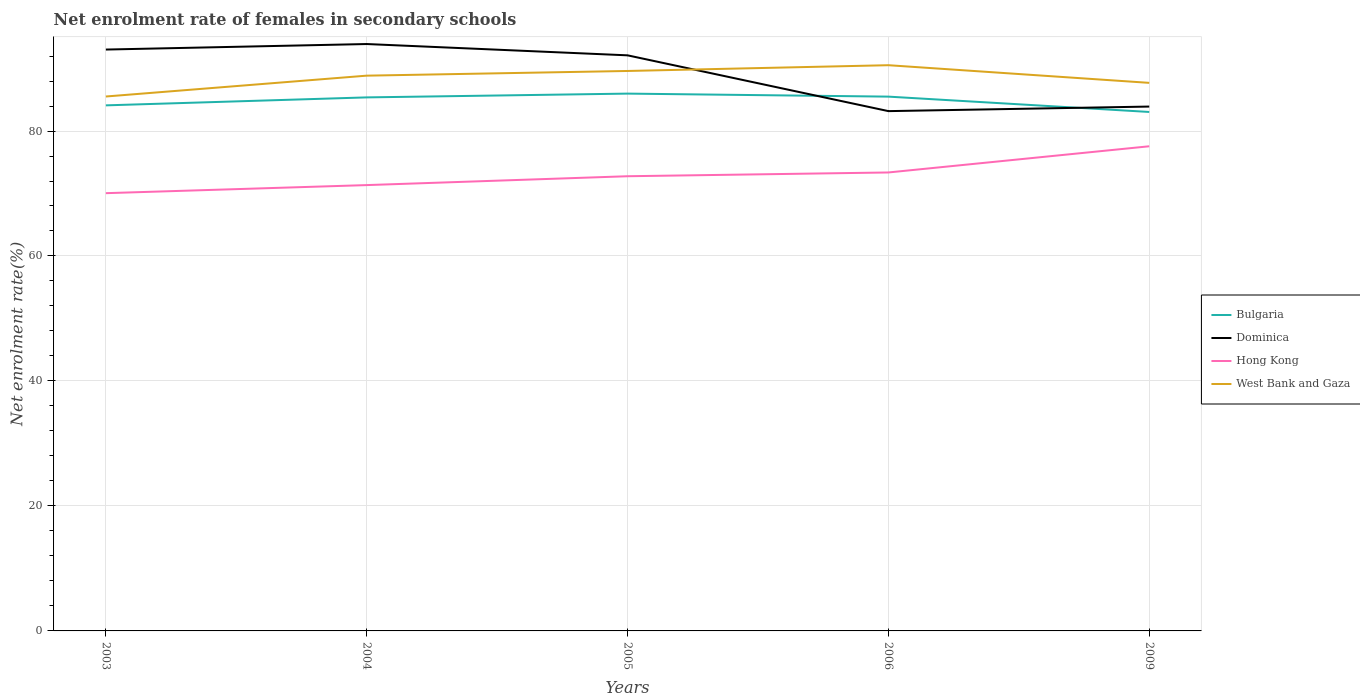Does the line corresponding to West Bank and Gaza intersect with the line corresponding to Dominica?
Provide a succinct answer. Yes. Is the number of lines equal to the number of legend labels?
Offer a terse response. Yes. Across all years, what is the maximum net enrolment rate of females in secondary schools in Hong Kong?
Provide a succinct answer. 70.05. What is the total net enrolment rate of females in secondary schools in Bulgaria in the graph?
Offer a very short reply. 0.48. What is the difference between the highest and the second highest net enrolment rate of females in secondary schools in Bulgaria?
Ensure brevity in your answer.  2.94. What is the difference between the highest and the lowest net enrolment rate of females in secondary schools in West Bank and Gaza?
Provide a short and direct response. 3. What is the difference between two consecutive major ticks on the Y-axis?
Keep it short and to the point. 20. Are the values on the major ticks of Y-axis written in scientific E-notation?
Give a very brief answer. No. Does the graph contain grids?
Your answer should be very brief. Yes. How many legend labels are there?
Make the answer very short. 4. What is the title of the graph?
Offer a terse response. Net enrolment rate of females in secondary schools. What is the label or title of the Y-axis?
Keep it short and to the point. Net enrolment rate(%). What is the Net enrolment rate(%) in Bulgaria in 2003?
Make the answer very short. 84.11. What is the Net enrolment rate(%) in Dominica in 2003?
Provide a short and direct response. 93.04. What is the Net enrolment rate(%) of Hong Kong in 2003?
Make the answer very short. 70.05. What is the Net enrolment rate(%) of West Bank and Gaza in 2003?
Provide a short and direct response. 85.52. What is the Net enrolment rate(%) in Bulgaria in 2004?
Make the answer very short. 85.38. What is the Net enrolment rate(%) of Dominica in 2004?
Give a very brief answer. 93.92. What is the Net enrolment rate(%) in Hong Kong in 2004?
Your answer should be very brief. 71.35. What is the Net enrolment rate(%) of West Bank and Gaza in 2004?
Your answer should be compact. 88.86. What is the Net enrolment rate(%) of Bulgaria in 2005?
Provide a succinct answer. 85.99. What is the Net enrolment rate(%) in Dominica in 2005?
Ensure brevity in your answer.  92.11. What is the Net enrolment rate(%) of Hong Kong in 2005?
Your response must be concise. 72.76. What is the Net enrolment rate(%) in West Bank and Gaza in 2005?
Keep it short and to the point. 89.61. What is the Net enrolment rate(%) in Bulgaria in 2006?
Offer a very short reply. 85.5. What is the Net enrolment rate(%) in Dominica in 2006?
Give a very brief answer. 83.18. What is the Net enrolment rate(%) of Hong Kong in 2006?
Your answer should be very brief. 73.37. What is the Net enrolment rate(%) of West Bank and Gaza in 2006?
Your answer should be compact. 90.53. What is the Net enrolment rate(%) in Bulgaria in 2009?
Offer a very short reply. 83.05. What is the Net enrolment rate(%) of Dominica in 2009?
Offer a very short reply. 83.91. What is the Net enrolment rate(%) of Hong Kong in 2009?
Your response must be concise. 77.56. What is the Net enrolment rate(%) of West Bank and Gaza in 2009?
Your answer should be very brief. 87.71. Across all years, what is the maximum Net enrolment rate(%) of Bulgaria?
Offer a terse response. 85.99. Across all years, what is the maximum Net enrolment rate(%) of Dominica?
Give a very brief answer. 93.92. Across all years, what is the maximum Net enrolment rate(%) in Hong Kong?
Make the answer very short. 77.56. Across all years, what is the maximum Net enrolment rate(%) of West Bank and Gaza?
Provide a short and direct response. 90.53. Across all years, what is the minimum Net enrolment rate(%) of Bulgaria?
Offer a very short reply. 83.05. Across all years, what is the minimum Net enrolment rate(%) in Dominica?
Your answer should be compact. 83.18. Across all years, what is the minimum Net enrolment rate(%) of Hong Kong?
Your answer should be very brief. 70.05. Across all years, what is the minimum Net enrolment rate(%) in West Bank and Gaza?
Keep it short and to the point. 85.52. What is the total Net enrolment rate(%) of Bulgaria in the graph?
Your answer should be compact. 424.02. What is the total Net enrolment rate(%) in Dominica in the graph?
Offer a very short reply. 446.16. What is the total Net enrolment rate(%) of Hong Kong in the graph?
Provide a succinct answer. 365.08. What is the total Net enrolment rate(%) of West Bank and Gaza in the graph?
Provide a succinct answer. 442.23. What is the difference between the Net enrolment rate(%) of Bulgaria in 2003 and that in 2004?
Your answer should be compact. -1.27. What is the difference between the Net enrolment rate(%) of Dominica in 2003 and that in 2004?
Your answer should be very brief. -0.88. What is the difference between the Net enrolment rate(%) of Hong Kong in 2003 and that in 2004?
Keep it short and to the point. -1.29. What is the difference between the Net enrolment rate(%) in West Bank and Gaza in 2003 and that in 2004?
Ensure brevity in your answer.  -3.34. What is the difference between the Net enrolment rate(%) of Bulgaria in 2003 and that in 2005?
Provide a succinct answer. -1.88. What is the difference between the Net enrolment rate(%) in Dominica in 2003 and that in 2005?
Your answer should be compact. 0.93. What is the difference between the Net enrolment rate(%) in Hong Kong in 2003 and that in 2005?
Your answer should be very brief. -2.71. What is the difference between the Net enrolment rate(%) in West Bank and Gaza in 2003 and that in 2005?
Make the answer very short. -4.08. What is the difference between the Net enrolment rate(%) of Bulgaria in 2003 and that in 2006?
Ensure brevity in your answer.  -1.4. What is the difference between the Net enrolment rate(%) in Dominica in 2003 and that in 2006?
Make the answer very short. 9.85. What is the difference between the Net enrolment rate(%) in Hong Kong in 2003 and that in 2006?
Your response must be concise. -3.31. What is the difference between the Net enrolment rate(%) of West Bank and Gaza in 2003 and that in 2006?
Provide a succinct answer. -5.01. What is the difference between the Net enrolment rate(%) in Bulgaria in 2003 and that in 2009?
Your answer should be compact. 1.06. What is the difference between the Net enrolment rate(%) in Dominica in 2003 and that in 2009?
Provide a short and direct response. 9.12. What is the difference between the Net enrolment rate(%) in Hong Kong in 2003 and that in 2009?
Provide a short and direct response. -7.5. What is the difference between the Net enrolment rate(%) in West Bank and Gaza in 2003 and that in 2009?
Your answer should be compact. -2.18. What is the difference between the Net enrolment rate(%) in Bulgaria in 2004 and that in 2005?
Ensure brevity in your answer.  -0.61. What is the difference between the Net enrolment rate(%) in Dominica in 2004 and that in 2005?
Make the answer very short. 1.81. What is the difference between the Net enrolment rate(%) in Hong Kong in 2004 and that in 2005?
Provide a succinct answer. -1.42. What is the difference between the Net enrolment rate(%) in West Bank and Gaza in 2004 and that in 2005?
Keep it short and to the point. -0.75. What is the difference between the Net enrolment rate(%) of Bulgaria in 2004 and that in 2006?
Your response must be concise. -0.12. What is the difference between the Net enrolment rate(%) of Dominica in 2004 and that in 2006?
Ensure brevity in your answer.  10.74. What is the difference between the Net enrolment rate(%) of Hong Kong in 2004 and that in 2006?
Give a very brief answer. -2.02. What is the difference between the Net enrolment rate(%) in West Bank and Gaza in 2004 and that in 2006?
Your answer should be very brief. -1.67. What is the difference between the Net enrolment rate(%) of Bulgaria in 2004 and that in 2009?
Make the answer very short. 2.33. What is the difference between the Net enrolment rate(%) of Dominica in 2004 and that in 2009?
Your answer should be very brief. 10.01. What is the difference between the Net enrolment rate(%) in Hong Kong in 2004 and that in 2009?
Your response must be concise. -6.21. What is the difference between the Net enrolment rate(%) in West Bank and Gaza in 2004 and that in 2009?
Offer a very short reply. 1.15. What is the difference between the Net enrolment rate(%) in Bulgaria in 2005 and that in 2006?
Keep it short and to the point. 0.48. What is the difference between the Net enrolment rate(%) in Dominica in 2005 and that in 2006?
Provide a succinct answer. 8.93. What is the difference between the Net enrolment rate(%) of Hong Kong in 2005 and that in 2006?
Offer a terse response. -0.6. What is the difference between the Net enrolment rate(%) of West Bank and Gaza in 2005 and that in 2006?
Your answer should be compact. -0.92. What is the difference between the Net enrolment rate(%) in Bulgaria in 2005 and that in 2009?
Give a very brief answer. 2.94. What is the difference between the Net enrolment rate(%) of Dominica in 2005 and that in 2009?
Give a very brief answer. 8.2. What is the difference between the Net enrolment rate(%) in Hong Kong in 2005 and that in 2009?
Your answer should be very brief. -4.8. What is the difference between the Net enrolment rate(%) of West Bank and Gaza in 2005 and that in 2009?
Your answer should be very brief. 1.9. What is the difference between the Net enrolment rate(%) in Bulgaria in 2006 and that in 2009?
Offer a very short reply. 2.46. What is the difference between the Net enrolment rate(%) in Dominica in 2006 and that in 2009?
Give a very brief answer. -0.73. What is the difference between the Net enrolment rate(%) in Hong Kong in 2006 and that in 2009?
Your answer should be very brief. -4.19. What is the difference between the Net enrolment rate(%) in West Bank and Gaza in 2006 and that in 2009?
Provide a succinct answer. 2.83. What is the difference between the Net enrolment rate(%) in Bulgaria in 2003 and the Net enrolment rate(%) in Dominica in 2004?
Keep it short and to the point. -9.81. What is the difference between the Net enrolment rate(%) of Bulgaria in 2003 and the Net enrolment rate(%) of Hong Kong in 2004?
Provide a short and direct response. 12.76. What is the difference between the Net enrolment rate(%) in Bulgaria in 2003 and the Net enrolment rate(%) in West Bank and Gaza in 2004?
Provide a short and direct response. -4.75. What is the difference between the Net enrolment rate(%) in Dominica in 2003 and the Net enrolment rate(%) in Hong Kong in 2004?
Offer a terse response. 21.69. What is the difference between the Net enrolment rate(%) of Dominica in 2003 and the Net enrolment rate(%) of West Bank and Gaza in 2004?
Offer a very short reply. 4.18. What is the difference between the Net enrolment rate(%) of Hong Kong in 2003 and the Net enrolment rate(%) of West Bank and Gaza in 2004?
Give a very brief answer. -18.81. What is the difference between the Net enrolment rate(%) in Bulgaria in 2003 and the Net enrolment rate(%) in Dominica in 2005?
Your response must be concise. -8. What is the difference between the Net enrolment rate(%) in Bulgaria in 2003 and the Net enrolment rate(%) in Hong Kong in 2005?
Your answer should be compact. 11.34. What is the difference between the Net enrolment rate(%) of Bulgaria in 2003 and the Net enrolment rate(%) of West Bank and Gaza in 2005?
Your response must be concise. -5.5. What is the difference between the Net enrolment rate(%) in Dominica in 2003 and the Net enrolment rate(%) in Hong Kong in 2005?
Provide a succinct answer. 20.27. What is the difference between the Net enrolment rate(%) in Dominica in 2003 and the Net enrolment rate(%) in West Bank and Gaza in 2005?
Keep it short and to the point. 3.43. What is the difference between the Net enrolment rate(%) in Hong Kong in 2003 and the Net enrolment rate(%) in West Bank and Gaza in 2005?
Provide a succinct answer. -19.55. What is the difference between the Net enrolment rate(%) of Bulgaria in 2003 and the Net enrolment rate(%) of Dominica in 2006?
Offer a very short reply. 0.92. What is the difference between the Net enrolment rate(%) of Bulgaria in 2003 and the Net enrolment rate(%) of Hong Kong in 2006?
Provide a short and direct response. 10.74. What is the difference between the Net enrolment rate(%) of Bulgaria in 2003 and the Net enrolment rate(%) of West Bank and Gaza in 2006?
Offer a very short reply. -6.43. What is the difference between the Net enrolment rate(%) of Dominica in 2003 and the Net enrolment rate(%) of Hong Kong in 2006?
Offer a terse response. 19.67. What is the difference between the Net enrolment rate(%) in Dominica in 2003 and the Net enrolment rate(%) in West Bank and Gaza in 2006?
Give a very brief answer. 2.5. What is the difference between the Net enrolment rate(%) in Hong Kong in 2003 and the Net enrolment rate(%) in West Bank and Gaza in 2006?
Provide a short and direct response. -20.48. What is the difference between the Net enrolment rate(%) of Bulgaria in 2003 and the Net enrolment rate(%) of Dominica in 2009?
Your response must be concise. 0.19. What is the difference between the Net enrolment rate(%) of Bulgaria in 2003 and the Net enrolment rate(%) of Hong Kong in 2009?
Offer a very short reply. 6.55. What is the difference between the Net enrolment rate(%) in Bulgaria in 2003 and the Net enrolment rate(%) in West Bank and Gaza in 2009?
Offer a very short reply. -3.6. What is the difference between the Net enrolment rate(%) of Dominica in 2003 and the Net enrolment rate(%) of Hong Kong in 2009?
Your answer should be compact. 15.48. What is the difference between the Net enrolment rate(%) in Dominica in 2003 and the Net enrolment rate(%) in West Bank and Gaza in 2009?
Give a very brief answer. 5.33. What is the difference between the Net enrolment rate(%) of Hong Kong in 2003 and the Net enrolment rate(%) of West Bank and Gaza in 2009?
Keep it short and to the point. -17.65. What is the difference between the Net enrolment rate(%) of Bulgaria in 2004 and the Net enrolment rate(%) of Dominica in 2005?
Offer a terse response. -6.73. What is the difference between the Net enrolment rate(%) in Bulgaria in 2004 and the Net enrolment rate(%) in Hong Kong in 2005?
Offer a terse response. 12.62. What is the difference between the Net enrolment rate(%) of Bulgaria in 2004 and the Net enrolment rate(%) of West Bank and Gaza in 2005?
Ensure brevity in your answer.  -4.23. What is the difference between the Net enrolment rate(%) in Dominica in 2004 and the Net enrolment rate(%) in Hong Kong in 2005?
Ensure brevity in your answer.  21.16. What is the difference between the Net enrolment rate(%) in Dominica in 2004 and the Net enrolment rate(%) in West Bank and Gaza in 2005?
Offer a terse response. 4.31. What is the difference between the Net enrolment rate(%) in Hong Kong in 2004 and the Net enrolment rate(%) in West Bank and Gaza in 2005?
Your answer should be very brief. -18.26. What is the difference between the Net enrolment rate(%) in Bulgaria in 2004 and the Net enrolment rate(%) in Dominica in 2006?
Give a very brief answer. 2.2. What is the difference between the Net enrolment rate(%) of Bulgaria in 2004 and the Net enrolment rate(%) of Hong Kong in 2006?
Provide a short and direct response. 12.01. What is the difference between the Net enrolment rate(%) of Bulgaria in 2004 and the Net enrolment rate(%) of West Bank and Gaza in 2006?
Your answer should be very brief. -5.15. What is the difference between the Net enrolment rate(%) in Dominica in 2004 and the Net enrolment rate(%) in Hong Kong in 2006?
Your answer should be compact. 20.55. What is the difference between the Net enrolment rate(%) in Dominica in 2004 and the Net enrolment rate(%) in West Bank and Gaza in 2006?
Your answer should be very brief. 3.39. What is the difference between the Net enrolment rate(%) in Hong Kong in 2004 and the Net enrolment rate(%) in West Bank and Gaza in 2006?
Your response must be concise. -19.19. What is the difference between the Net enrolment rate(%) of Bulgaria in 2004 and the Net enrolment rate(%) of Dominica in 2009?
Provide a short and direct response. 1.47. What is the difference between the Net enrolment rate(%) of Bulgaria in 2004 and the Net enrolment rate(%) of Hong Kong in 2009?
Keep it short and to the point. 7.82. What is the difference between the Net enrolment rate(%) in Bulgaria in 2004 and the Net enrolment rate(%) in West Bank and Gaza in 2009?
Your response must be concise. -2.33. What is the difference between the Net enrolment rate(%) in Dominica in 2004 and the Net enrolment rate(%) in Hong Kong in 2009?
Your answer should be very brief. 16.36. What is the difference between the Net enrolment rate(%) in Dominica in 2004 and the Net enrolment rate(%) in West Bank and Gaza in 2009?
Offer a terse response. 6.21. What is the difference between the Net enrolment rate(%) of Hong Kong in 2004 and the Net enrolment rate(%) of West Bank and Gaza in 2009?
Give a very brief answer. -16.36. What is the difference between the Net enrolment rate(%) in Bulgaria in 2005 and the Net enrolment rate(%) in Dominica in 2006?
Provide a succinct answer. 2.8. What is the difference between the Net enrolment rate(%) in Bulgaria in 2005 and the Net enrolment rate(%) in Hong Kong in 2006?
Your answer should be very brief. 12.62. What is the difference between the Net enrolment rate(%) of Bulgaria in 2005 and the Net enrolment rate(%) of West Bank and Gaza in 2006?
Ensure brevity in your answer.  -4.55. What is the difference between the Net enrolment rate(%) in Dominica in 2005 and the Net enrolment rate(%) in Hong Kong in 2006?
Offer a terse response. 18.74. What is the difference between the Net enrolment rate(%) of Dominica in 2005 and the Net enrolment rate(%) of West Bank and Gaza in 2006?
Offer a very short reply. 1.58. What is the difference between the Net enrolment rate(%) of Hong Kong in 2005 and the Net enrolment rate(%) of West Bank and Gaza in 2006?
Your answer should be very brief. -17.77. What is the difference between the Net enrolment rate(%) in Bulgaria in 2005 and the Net enrolment rate(%) in Dominica in 2009?
Ensure brevity in your answer.  2.07. What is the difference between the Net enrolment rate(%) of Bulgaria in 2005 and the Net enrolment rate(%) of Hong Kong in 2009?
Ensure brevity in your answer.  8.43. What is the difference between the Net enrolment rate(%) in Bulgaria in 2005 and the Net enrolment rate(%) in West Bank and Gaza in 2009?
Your answer should be compact. -1.72. What is the difference between the Net enrolment rate(%) in Dominica in 2005 and the Net enrolment rate(%) in Hong Kong in 2009?
Offer a very short reply. 14.55. What is the difference between the Net enrolment rate(%) of Dominica in 2005 and the Net enrolment rate(%) of West Bank and Gaza in 2009?
Your response must be concise. 4.4. What is the difference between the Net enrolment rate(%) in Hong Kong in 2005 and the Net enrolment rate(%) in West Bank and Gaza in 2009?
Your answer should be very brief. -14.94. What is the difference between the Net enrolment rate(%) in Bulgaria in 2006 and the Net enrolment rate(%) in Dominica in 2009?
Make the answer very short. 1.59. What is the difference between the Net enrolment rate(%) of Bulgaria in 2006 and the Net enrolment rate(%) of Hong Kong in 2009?
Offer a very short reply. 7.95. What is the difference between the Net enrolment rate(%) in Bulgaria in 2006 and the Net enrolment rate(%) in West Bank and Gaza in 2009?
Offer a terse response. -2.2. What is the difference between the Net enrolment rate(%) of Dominica in 2006 and the Net enrolment rate(%) of Hong Kong in 2009?
Offer a terse response. 5.63. What is the difference between the Net enrolment rate(%) of Dominica in 2006 and the Net enrolment rate(%) of West Bank and Gaza in 2009?
Make the answer very short. -4.52. What is the difference between the Net enrolment rate(%) of Hong Kong in 2006 and the Net enrolment rate(%) of West Bank and Gaza in 2009?
Keep it short and to the point. -14.34. What is the average Net enrolment rate(%) in Bulgaria per year?
Ensure brevity in your answer.  84.8. What is the average Net enrolment rate(%) in Dominica per year?
Your answer should be very brief. 89.23. What is the average Net enrolment rate(%) of Hong Kong per year?
Keep it short and to the point. 73.02. What is the average Net enrolment rate(%) of West Bank and Gaza per year?
Offer a very short reply. 88.45. In the year 2003, what is the difference between the Net enrolment rate(%) in Bulgaria and Net enrolment rate(%) in Dominica?
Your answer should be compact. -8.93. In the year 2003, what is the difference between the Net enrolment rate(%) of Bulgaria and Net enrolment rate(%) of Hong Kong?
Make the answer very short. 14.05. In the year 2003, what is the difference between the Net enrolment rate(%) of Bulgaria and Net enrolment rate(%) of West Bank and Gaza?
Give a very brief answer. -1.42. In the year 2003, what is the difference between the Net enrolment rate(%) in Dominica and Net enrolment rate(%) in Hong Kong?
Make the answer very short. 22.98. In the year 2003, what is the difference between the Net enrolment rate(%) in Dominica and Net enrolment rate(%) in West Bank and Gaza?
Offer a terse response. 7.51. In the year 2003, what is the difference between the Net enrolment rate(%) in Hong Kong and Net enrolment rate(%) in West Bank and Gaza?
Give a very brief answer. -15.47. In the year 2004, what is the difference between the Net enrolment rate(%) in Bulgaria and Net enrolment rate(%) in Dominica?
Offer a very short reply. -8.54. In the year 2004, what is the difference between the Net enrolment rate(%) of Bulgaria and Net enrolment rate(%) of Hong Kong?
Ensure brevity in your answer.  14.03. In the year 2004, what is the difference between the Net enrolment rate(%) in Bulgaria and Net enrolment rate(%) in West Bank and Gaza?
Provide a short and direct response. -3.48. In the year 2004, what is the difference between the Net enrolment rate(%) in Dominica and Net enrolment rate(%) in Hong Kong?
Your answer should be very brief. 22.57. In the year 2004, what is the difference between the Net enrolment rate(%) in Dominica and Net enrolment rate(%) in West Bank and Gaza?
Keep it short and to the point. 5.06. In the year 2004, what is the difference between the Net enrolment rate(%) of Hong Kong and Net enrolment rate(%) of West Bank and Gaza?
Your answer should be very brief. -17.51. In the year 2005, what is the difference between the Net enrolment rate(%) of Bulgaria and Net enrolment rate(%) of Dominica?
Make the answer very short. -6.12. In the year 2005, what is the difference between the Net enrolment rate(%) in Bulgaria and Net enrolment rate(%) in Hong Kong?
Offer a very short reply. 13.22. In the year 2005, what is the difference between the Net enrolment rate(%) of Bulgaria and Net enrolment rate(%) of West Bank and Gaza?
Offer a very short reply. -3.62. In the year 2005, what is the difference between the Net enrolment rate(%) of Dominica and Net enrolment rate(%) of Hong Kong?
Provide a short and direct response. 19.35. In the year 2005, what is the difference between the Net enrolment rate(%) of Dominica and Net enrolment rate(%) of West Bank and Gaza?
Your answer should be compact. 2.5. In the year 2005, what is the difference between the Net enrolment rate(%) of Hong Kong and Net enrolment rate(%) of West Bank and Gaza?
Provide a succinct answer. -16.85. In the year 2006, what is the difference between the Net enrolment rate(%) of Bulgaria and Net enrolment rate(%) of Dominica?
Your answer should be very brief. 2.32. In the year 2006, what is the difference between the Net enrolment rate(%) of Bulgaria and Net enrolment rate(%) of Hong Kong?
Offer a very short reply. 12.14. In the year 2006, what is the difference between the Net enrolment rate(%) in Bulgaria and Net enrolment rate(%) in West Bank and Gaza?
Offer a terse response. -5.03. In the year 2006, what is the difference between the Net enrolment rate(%) in Dominica and Net enrolment rate(%) in Hong Kong?
Offer a terse response. 9.82. In the year 2006, what is the difference between the Net enrolment rate(%) of Dominica and Net enrolment rate(%) of West Bank and Gaza?
Provide a succinct answer. -7.35. In the year 2006, what is the difference between the Net enrolment rate(%) of Hong Kong and Net enrolment rate(%) of West Bank and Gaza?
Provide a succinct answer. -17.17. In the year 2009, what is the difference between the Net enrolment rate(%) of Bulgaria and Net enrolment rate(%) of Dominica?
Give a very brief answer. -0.86. In the year 2009, what is the difference between the Net enrolment rate(%) of Bulgaria and Net enrolment rate(%) of Hong Kong?
Keep it short and to the point. 5.49. In the year 2009, what is the difference between the Net enrolment rate(%) in Bulgaria and Net enrolment rate(%) in West Bank and Gaza?
Make the answer very short. -4.66. In the year 2009, what is the difference between the Net enrolment rate(%) of Dominica and Net enrolment rate(%) of Hong Kong?
Offer a terse response. 6.36. In the year 2009, what is the difference between the Net enrolment rate(%) of Dominica and Net enrolment rate(%) of West Bank and Gaza?
Make the answer very short. -3.79. In the year 2009, what is the difference between the Net enrolment rate(%) in Hong Kong and Net enrolment rate(%) in West Bank and Gaza?
Ensure brevity in your answer.  -10.15. What is the ratio of the Net enrolment rate(%) in Bulgaria in 2003 to that in 2004?
Offer a terse response. 0.99. What is the ratio of the Net enrolment rate(%) in Dominica in 2003 to that in 2004?
Offer a terse response. 0.99. What is the ratio of the Net enrolment rate(%) in Hong Kong in 2003 to that in 2004?
Offer a terse response. 0.98. What is the ratio of the Net enrolment rate(%) of West Bank and Gaza in 2003 to that in 2004?
Offer a terse response. 0.96. What is the ratio of the Net enrolment rate(%) of Bulgaria in 2003 to that in 2005?
Give a very brief answer. 0.98. What is the ratio of the Net enrolment rate(%) of Dominica in 2003 to that in 2005?
Provide a succinct answer. 1.01. What is the ratio of the Net enrolment rate(%) in Hong Kong in 2003 to that in 2005?
Keep it short and to the point. 0.96. What is the ratio of the Net enrolment rate(%) in West Bank and Gaza in 2003 to that in 2005?
Provide a short and direct response. 0.95. What is the ratio of the Net enrolment rate(%) in Bulgaria in 2003 to that in 2006?
Give a very brief answer. 0.98. What is the ratio of the Net enrolment rate(%) of Dominica in 2003 to that in 2006?
Offer a terse response. 1.12. What is the ratio of the Net enrolment rate(%) in Hong Kong in 2003 to that in 2006?
Your answer should be very brief. 0.95. What is the ratio of the Net enrolment rate(%) of West Bank and Gaza in 2003 to that in 2006?
Give a very brief answer. 0.94. What is the ratio of the Net enrolment rate(%) of Bulgaria in 2003 to that in 2009?
Give a very brief answer. 1.01. What is the ratio of the Net enrolment rate(%) in Dominica in 2003 to that in 2009?
Ensure brevity in your answer.  1.11. What is the ratio of the Net enrolment rate(%) in Hong Kong in 2003 to that in 2009?
Your answer should be very brief. 0.9. What is the ratio of the Net enrolment rate(%) in West Bank and Gaza in 2003 to that in 2009?
Offer a very short reply. 0.98. What is the ratio of the Net enrolment rate(%) of Dominica in 2004 to that in 2005?
Your response must be concise. 1.02. What is the ratio of the Net enrolment rate(%) of Hong Kong in 2004 to that in 2005?
Your answer should be compact. 0.98. What is the ratio of the Net enrolment rate(%) of West Bank and Gaza in 2004 to that in 2005?
Provide a short and direct response. 0.99. What is the ratio of the Net enrolment rate(%) of Dominica in 2004 to that in 2006?
Your answer should be compact. 1.13. What is the ratio of the Net enrolment rate(%) of Hong Kong in 2004 to that in 2006?
Give a very brief answer. 0.97. What is the ratio of the Net enrolment rate(%) of West Bank and Gaza in 2004 to that in 2006?
Your answer should be very brief. 0.98. What is the ratio of the Net enrolment rate(%) in Bulgaria in 2004 to that in 2009?
Your response must be concise. 1.03. What is the ratio of the Net enrolment rate(%) in Dominica in 2004 to that in 2009?
Your response must be concise. 1.12. What is the ratio of the Net enrolment rate(%) in Hong Kong in 2004 to that in 2009?
Your response must be concise. 0.92. What is the ratio of the Net enrolment rate(%) in West Bank and Gaza in 2004 to that in 2009?
Offer a very short reply. 1.01. What is the ratio of the Net enrolment rate(%) in Bulgaria in 2005 to that in 2006?
Your answer should be very brief. 1.01. What is the ratio of the Net enrolment rate(%) of Dominica in 2005 to that in 2006?
Keep it short and to the point. 1.11. What is the ratio of the Net enrolment rate(%) of West Bank and Gaza in 2005 to that in 2006?
Ensure brevity in your answer.  0.99. What is the ratio of the Net enrolment rate(%) in Bulgaria in 2005 to that in 2009?
Your answer should be very brief. 1.04. What is the ratio of the Net enrolment rate(%) of Dominica in 2005 to that in 2009?
Provide a succinct answer. 1.1. What is the ratio of the Net enrolment rate(%) in Hong Kong in 2005 to that in 2009?
Make the answer very short. 0.94. What is the ratio of the Net enrolment rate(%) in West Bank and Gaza in 2005 to that in 2009?
Keep it short and to the point. 1.02. What is the ratio of the Net enrolment rate(%) of Bulgaria in 2006 to that in 2009?
Provide a short and direct response. 1.03. What is the ratio of the Net enrolment rate(%) of Hong Kong in 2006 to that in 2009?
Provide a short and direct response. 0.95. What is the ratio of the Net enrolment rate(%) of West Bank and Gaza in 2006 to that in 2009?
Offer a terse response. 1.03. What is the difference between the highest and the second highest Net enrolment rate(%) of Bulgaria?
Ensure brevity in your answer.  0.48. What is the difference between the highest and the second highest Net enrolment rate(%) of Dominica?
Ensure brevity in your answer.  0.88. What is the difference between the highest and the second highest Net enrolment rate(%) of Hong Kong?
Give a very brief answer. 4.19. What is the difference between the highest and the second highest Net enrolment rate(%) of West Bank and Gaza?
Provide a succinct answer. 0.92. What is the difference between the highest and the lowest Net enrolment rate(%) in Bulgaria?
Ensure brevity in your answer.  2.94. What is the difference between the highest and the lowest Net enrolment rate(%) in Dominica?
Your answer should be very brief. 10.74. What is the difference between the highest and the lowest Net enrolment rate(%) of Hong Kong?
Give a very brief answer. 7.5. What is the difference between the highest and the lowest Net enrolment rate(%) in West Bank and Gaza?
Give a very brief answer. 5.01. 